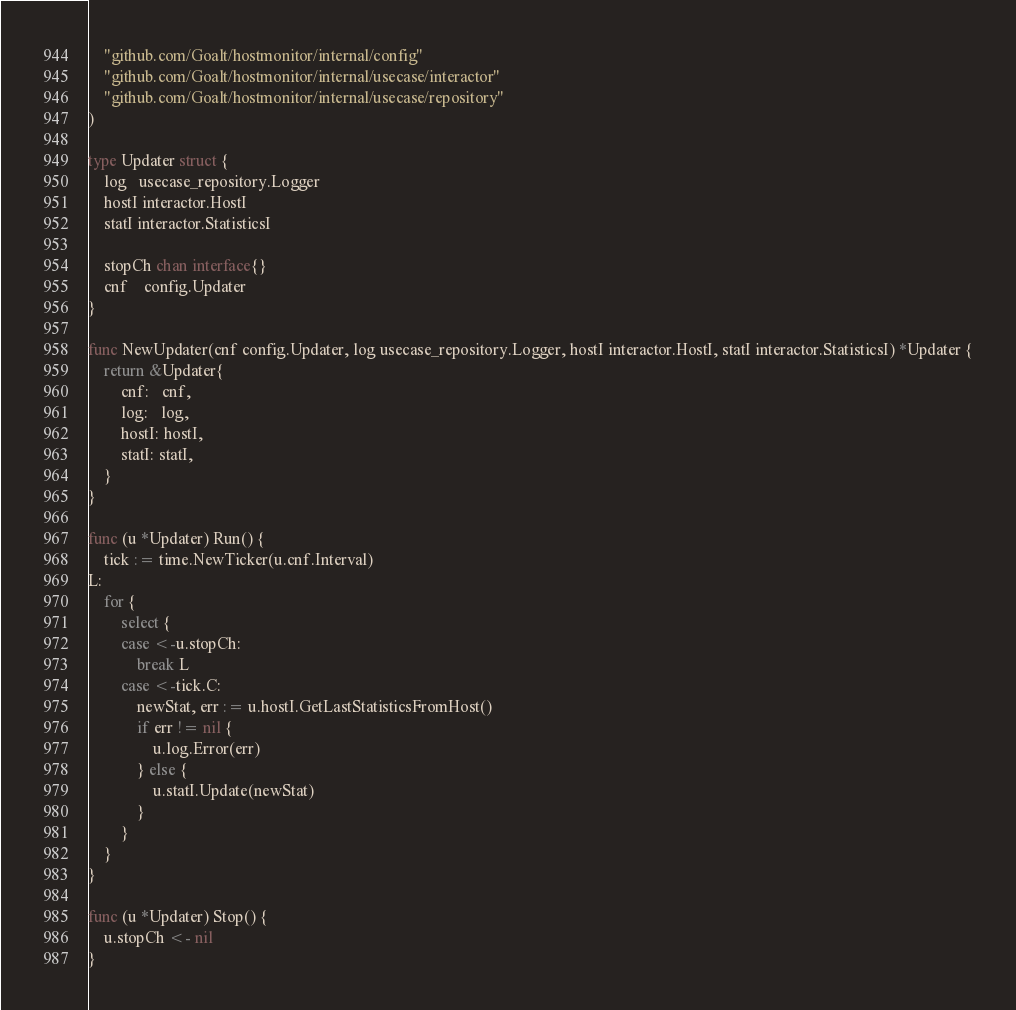Convert code to text. <code><loc_0><loc_0><loc_500><loc_500><_Go_>	"github.com/Goalt/hostmonitor/internal/config"
	"github.com/Goalt/hostmonitor/internal/usecase/interactor"
	"github.com/Goalt/hostmonitor/internal/usecase/repository"
)

type Updater struct {
	log   usecase_repository.Logger
	hostI interactor.HostI
	statI interactor.StatisticsI

	stopCh chan interface{}
	cnf    config.Updater
}

func NewUpdater(cnf config.Updater, log usecase_repository.Logger, hostI interactor.HostI, statI interactor.StatisticsI) *Updater {
	return &Updater{
		cnf:   cnf,
		log:   log,
		hostI: hostI,
		statI: statI,
	}
}

func (u *Updater) Run() {
	tick := time.NewTicker(u.cnf.Interval)
L:
	for {
		select {
		case <-u.stopCh:
			break L
		case <-tick.C:
			newStat, err := u.hostI.GetLastStatisticsFromHost()
			if err != nil {
				u.log.Error(err)
			} else {
				u.statI.Update(newStat)
			}
		}
	}
}

func (u *Updater) Stop() {
	u.stopCh <- nil
}
</code> 